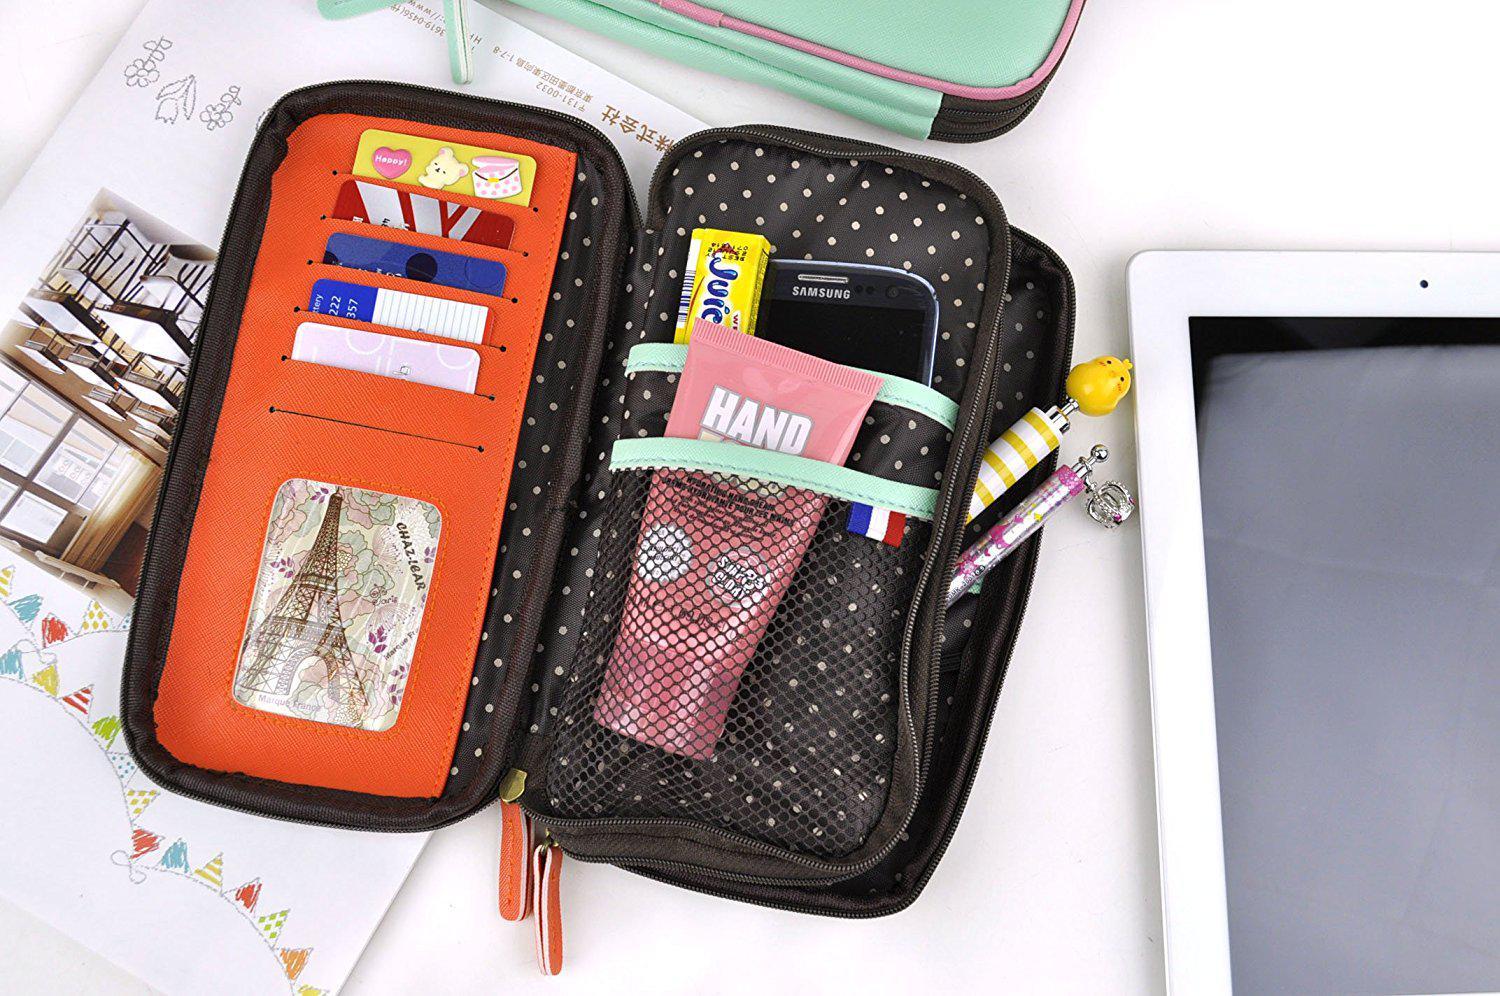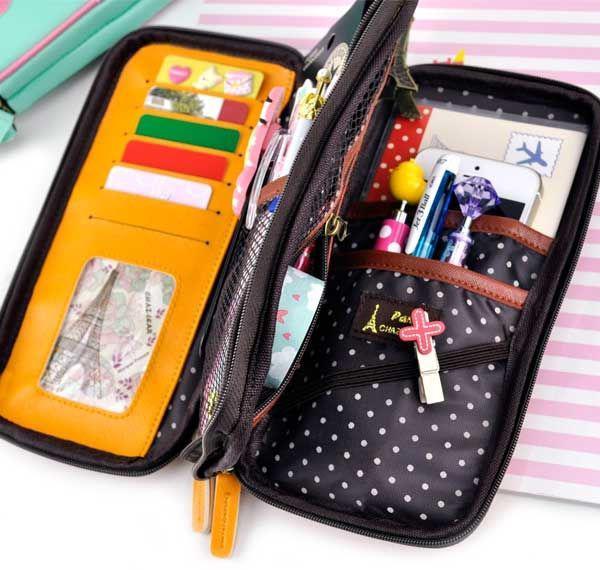The first image is the image on the left, the second image is the image on the right. Considering the images on both sides, is "At least one of the pouches contains an Eiffel tower object." valid? Answer yes or no. Yes. The first image is the image on the left, the second image is the image on the right. Considering the images on both sides, is "At least one image shows an open zipper case with rounded corners and a polka-dotted black interior filled with supplies." valid? Answer yes or no. Yes. 